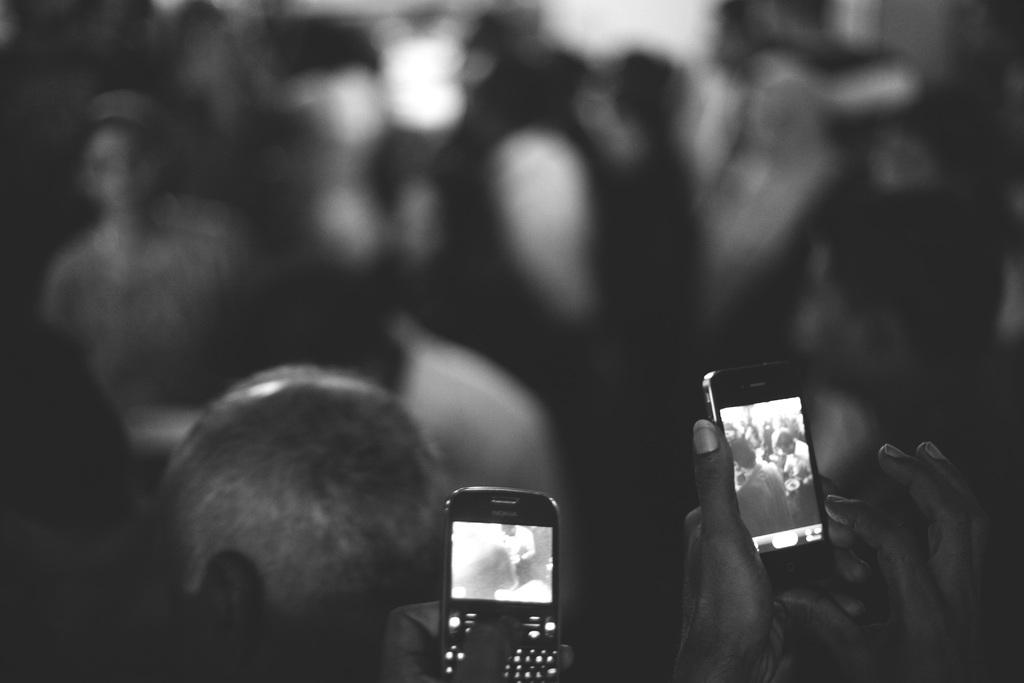How many people are visible in the image? There are two persons in the image. What are the two persons holding in their hands? The two persons are holding mobiles. Can you describe the background of the image? The background is blurred, and there are many people visible. What type of haircut does the police officer have in the image? There is no police officer or any reference to haircuts in the image. 